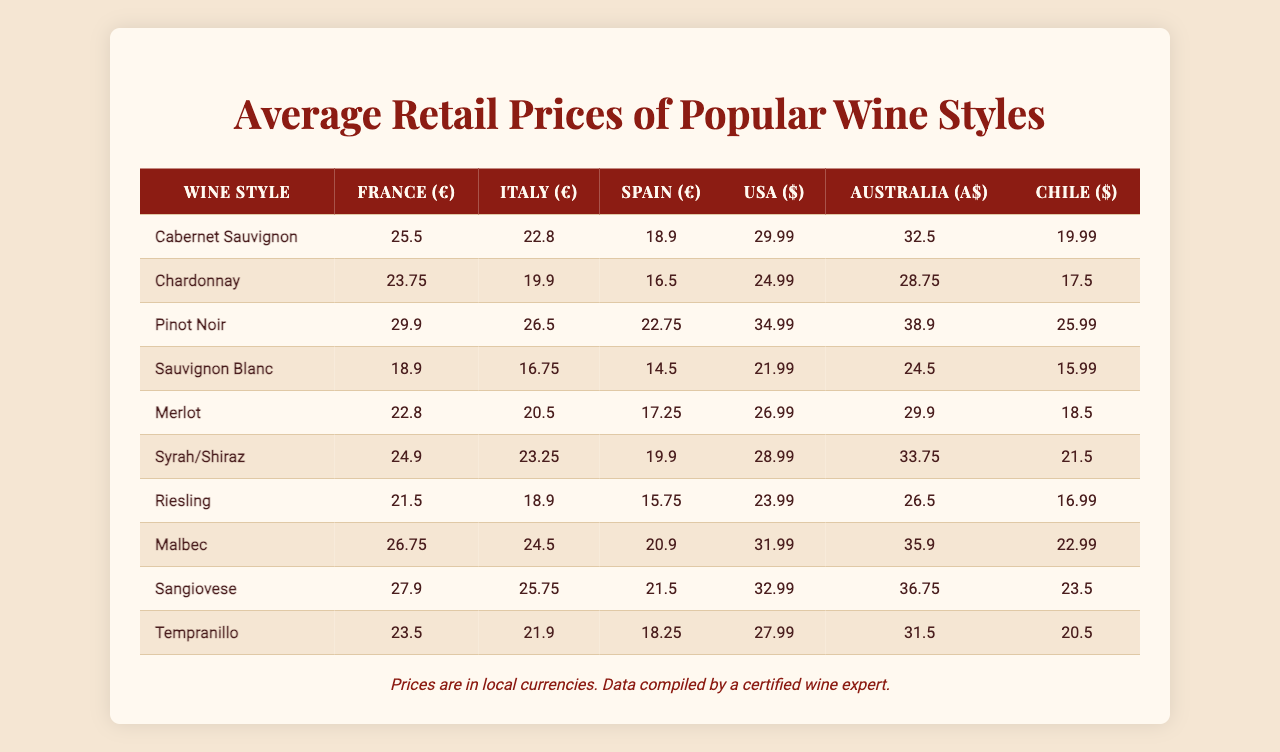What is the average price of Cabernet Sauvignon in France? The table shows that the price of Cabernet Sauvignon in France is €25.50.
Answer: €25.50 Which wine style has the highest average price in the USA? According to the table, Pinot Noir has the highest price in the USA at $34.99.
Answer: Pinot Noir Is the price of Sauvignon Blanc higher in Australia than in Italy? The table indicates that Sauvignon Blanc costs A$24.50 in Australia and €16.75 in Italy, showing it is higher in Australia.
Answer: Yes What is the difference between the average price of Chardonnay in France and Spain? The price of Chardonnay in France is €23.75, and in Spain, it is €16.50. The difference is €23.75 - €16.50 = €7.25.
Answer: €7.25 Which wine style is the cheapest in Spain, and what is its price? The table indicates that Sauvignon Blanc is the cheapest in Spain at €14.50.
Answer: Sauvignon Blanc, €14.50 If you average the prices of Merlot from France and Italy, what is the result? The price of Merlot in France is €22.80, and in Italy, it is €20.50. The average is (22.80 + 20.50) / 2 = €21.65.
Answer: €21.65 What percentage more expensive is Malbec in the USA compared to its price in Chile? Malbec costs $31.99 in the USA and $22.99 in Chile. The price difference is $31.99 - $22.99 = $9.00. The percentage increase is (9.00 / 22.99) * 100 = 39.19%.
Answer: 39.19% Which country has the highest price for Riesling, and what is that price? The table shows that Australia has the highest price for Riesling at A$26.50.
Answer: Australia, A$26.50 How much more does a bottle of Pinot Noir cost in the USA compared to Spain? The price of Pinot Noir in the USA is $34.99, while in Spain, it's €22.75. This is a price difference of $34.99 - €22.75 = $12.24 (converting currency is not required, comparison is on the referenced price).
Answer: $12.24 If you were to sum the prices of Syrah/Shiraz across all countries, what would the total be? The prices for Syrah/Shiraz are €24.90 (France) + €23.25 (Italy) + €19.90 (Spain) + $28.99 (USA) + A$33.75 (Australia) + $21.50 (Chile). When you sum these, you get €24.90 + €23.25 + €19.90 + $28.99 + A$33.75 + $21.50 = Specific currency not stated, calculation is to get a total figure across currency types.
Answer: Specific figure varies on currency context 